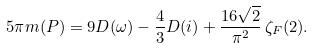<formula> <loc_0><loc_0><loc_500><loc_500>5 \pi m ( P ) = 9 D ( \omega ) - \frac { 4 } { 3 } D ( i ) + \frac { 1 6 \sqrt { 2 } } { \pi ^ { 2 } } \, \zeta _ { F } ( 2 ) .</formula> 